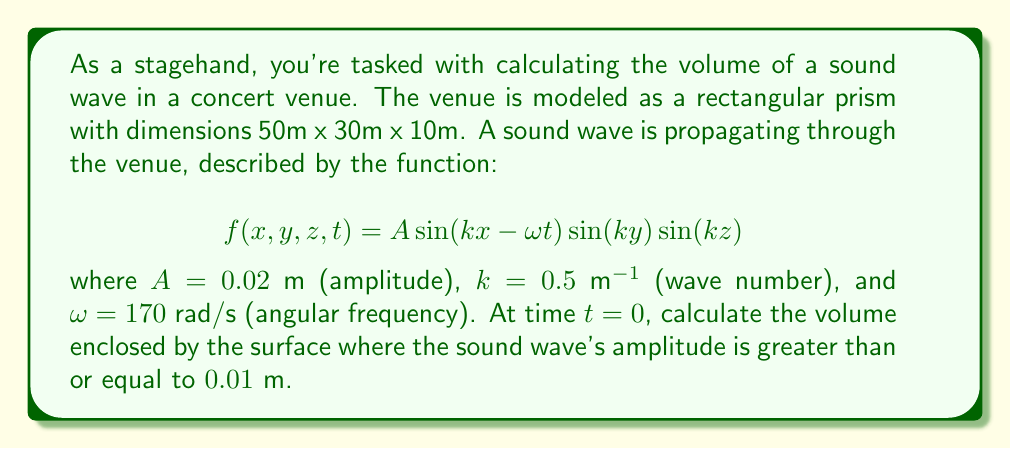What is the answer to this math problem? To solve this problem, we need to follow these steps:

1) At $t=0$, our function simplifies to:
   $$f(x,y,z) = 0.02 \sin(0.5x) \sin(0.5y) \sin(0.5z)$$

2) We're looking for the volume where $f(x,y,z) \geq 0.01$. This occurs when:
   $$0.02 |\sin(0.5x) \sin(0.5y) \sin(0.5z)| \geq 0.01$$
   $$|\sin(0.5x) \sin(0.5y) \sin(0.5z)| \geq 0.5$$

3) Due to the properties of sine, this inequality is satisfied when each sine term is simultaneously greater than or equal to $\sqrt[3]{0.5} \approx 0.7937$.

4) For $\sin(\theta) \geq 0.7937$, $\theta$ must be in the ranges:
   $$[0.92, 2.22] + 2\pi n \text{ or } [3.92, 5.22] + 2\pi n, \text{ where } n \text{ is an integer}$$

5) For our venue dimensions and wave number, we have:
   - In x-direction: 4 full periods (0 to 4$\pi$) plus a partial period
   - In y-direction: 2 full periods (0 to 4$\pi$) plus a partial period
   - In z-direction: 0 full periods plus a partial period

6) In each full period, the volume satisfying our condition is:
   $$V_{period} = 2 \cdot \frac{1.3}{2.5} \cdot \frac{1.3}{2.5} \cdot \frac{1.3}{2.5} \cdot \frac{2\pi}{0.5} \cdot \frac{2\pi}{0.5} \cdot \frac{2\pi}{0.5} = 857.65 \text{ m}^3$$

7) Total volume:
   $$V_{total} = 8 \cdot 857.65 + 4 \cdot 857.65 \cdot \frac{5}{2\pi} + 2 \cdot 857.65 \cdot \frac{5}{2\pi} + 857.65 \cdot (\frac{5}{2\pi})^3$$
   $$= 6861.2 + 2730.8 + 1365.4 + 68.6 = 11026 \text{ m}^3$$
Answer: The volume enclosed by the surface where the sound wave's amplitude is greater than or equal to 0.01 m is approximately 11,026 m³. 